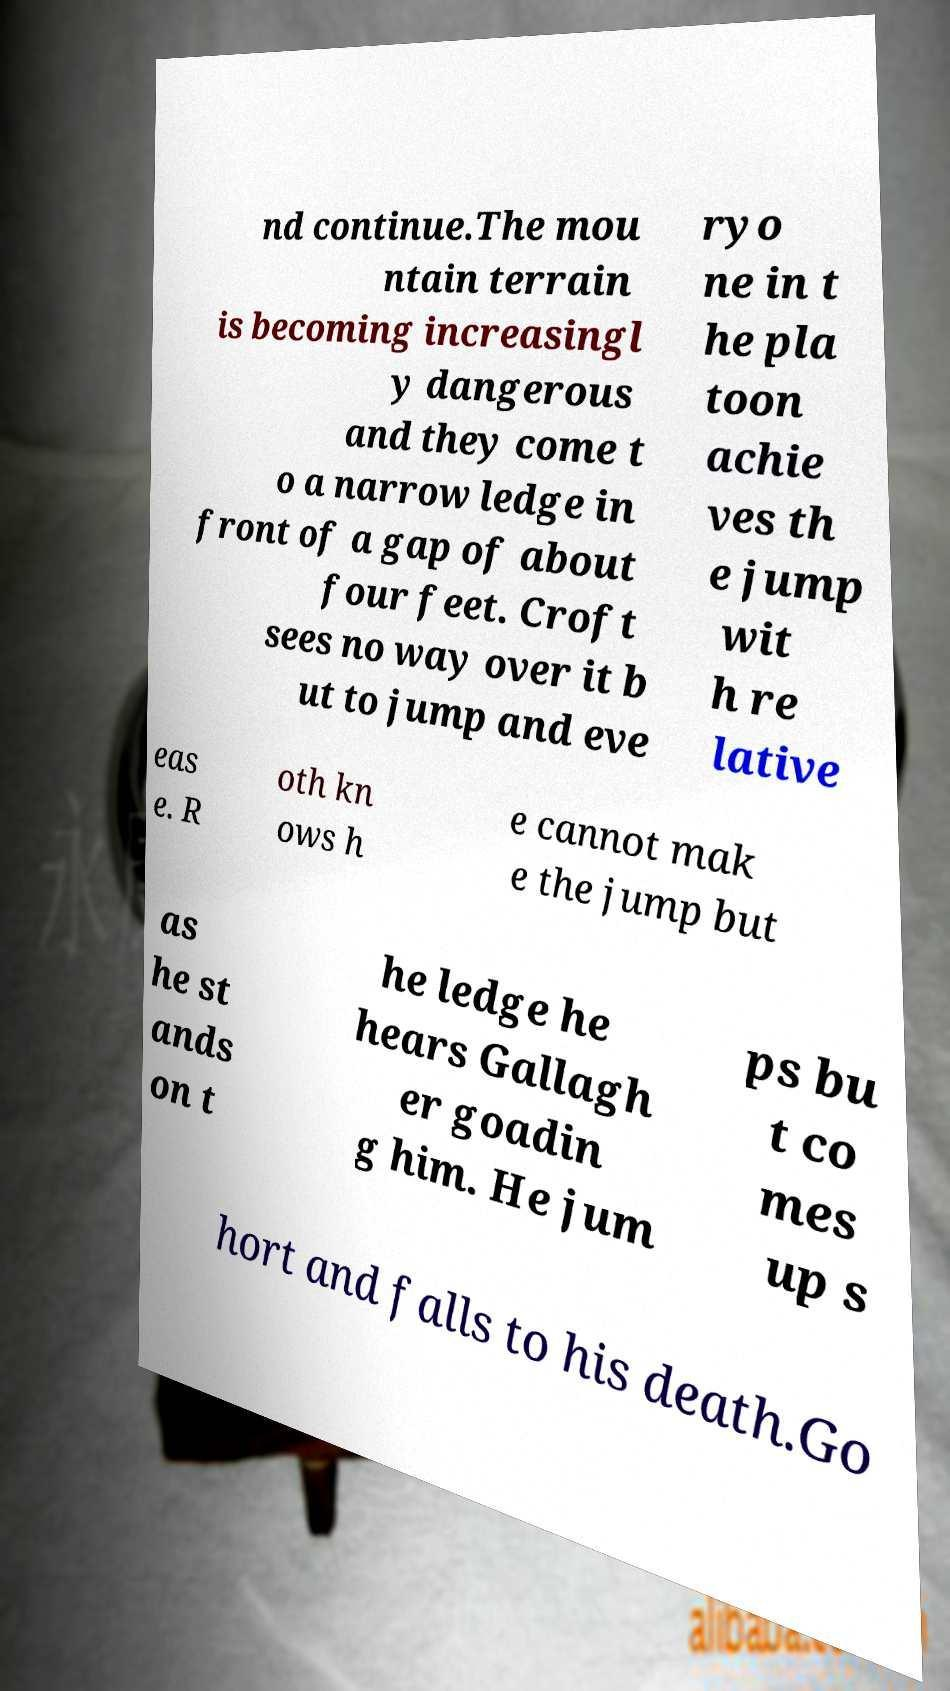Please identify and transcribe the text found in this image. nd continue.The mou ntain terrain is becoming increasingl y dangerous and they come t o a narrow ledge in front of a gap of about four feet. Croft sees no way over it b ut to jump and eve ryo ne in t he pla toon achie ves th e jump wit h re lative eas e. R oth kn ows h e cannot mak e the jump but as he st ands on t he ledge he hears Gallagh er goadin g him. He jum ps bu t co mes up s hort and falls to his death.Go 